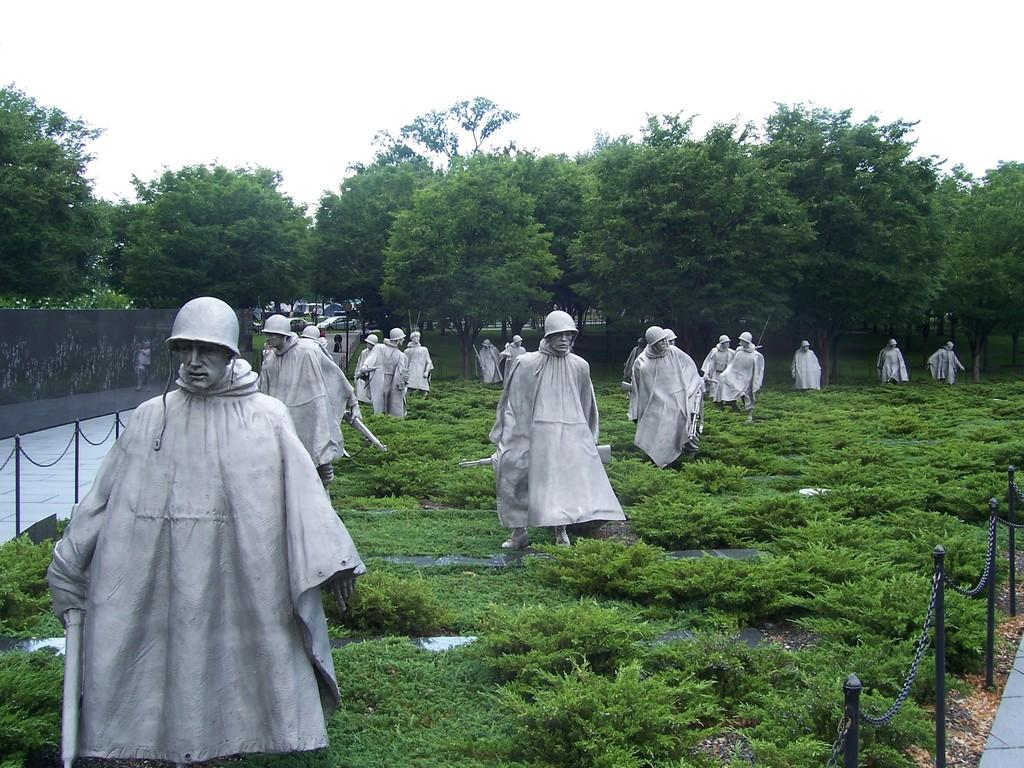What type of objects can be seen in the image? There are statues in the image. What architectural feature is present in the image? There is a fence in the image. What can be seen in the background of the image? There is a wall, trees, cars, a walkway, and the sky visible in the background of the image. Can you see your friend cooking on the stove near the sea in the image? There is no friend, stove, or sea present in the image. 